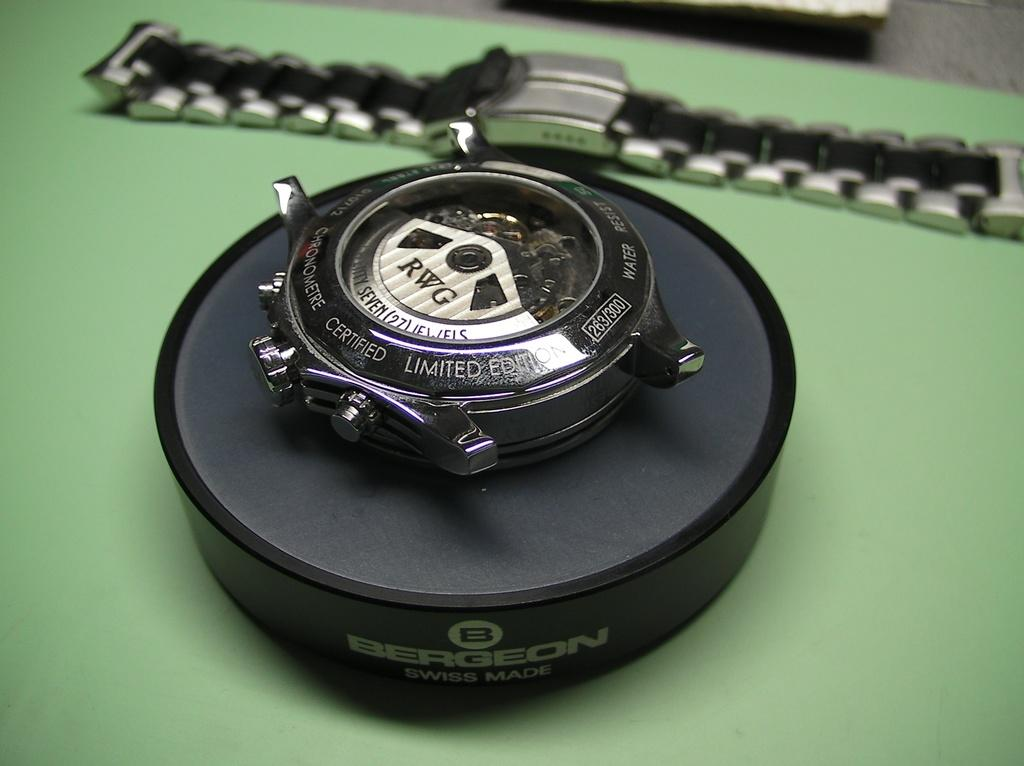<image>
Write a terse but informative summary of the picture. Face of a watch which says the letters RWG on it. 